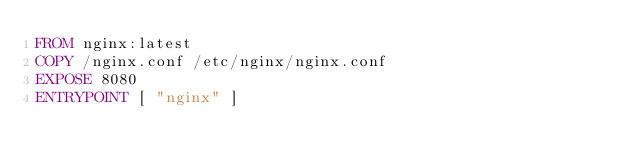Convert code to text. <code><loc_0><loc_0><loc_500><loc_500><_Dockerfile_>FROM nginx:latest
COPY /nginx.conf /etc/nginx/nginx.conf
EXPOSE 8080
ENTRYPOINT [ "nginx" ]
</code> 